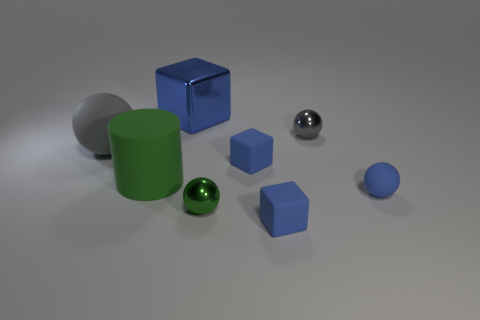What number of gray things are there?
Offer a terse response. 2. What is the shape of the big metal object?
Provide a short and direct response. Cube. What number of gray matte things have the same size as the cylinder?
Give a very brief answer. 1. Is the big green rubber object the same shape as the big blue metal object?
Ensure brevity in your answer.  No. The small block that is behind the green thing to the right of the blue shiny block is what color?
Give a very brief answer. Blue. There is a ball that is in front of the gray rubber sphere and left of the small blue sphere; what size is it?
Provide a short and direct response. Small. Is there any other thing that has the same color as the large shiny cube?
Your answer should be compact. Yes. What shape is the big gray object that is the same material as the cylinder?
Provide a succinct answer. Sphere. Does the big shiny object have the same shape as the gray object to the right of the big blue block?
Your answer should be very brief. No. What is the material of the small cube behind the tiny blue rubber cube that is in front of the tiny green object?
Provide a short and direct response. Rubber. 